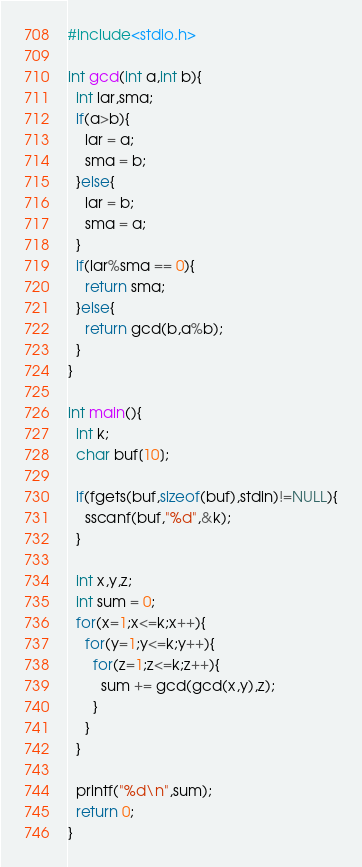<code> <loc_0><loc_0><loc_500><loc_500><_C_>#include<stdio.h>

int gcd(int a,int b){
  int lar,sma;
  if(a>b){
    lar = a;
    sma = b;
  }else{
    lar = b;
    sma = a;
  }
  if(lar%sma == 0){
    return sma;
  }else{
    return gcd(b,a%b);
  }
}

int main(){
  int k;
  char buf[10];

  if(fgets(buf,sizeof(buf),stdin)!=NULL){
    sscanf(buf,"%d",&k);
  }

  int x,y,z;
  int sum = 0;
  for(x=1;x<=k;x++){
    for(y=1;y<=k;y++){
      for(z=1;z<=k;z++){
        sum += gcd(gcd(x,y),z);
      }
    }
  }

  printf("%d\n",sum);
  return 0;
}
</code> 